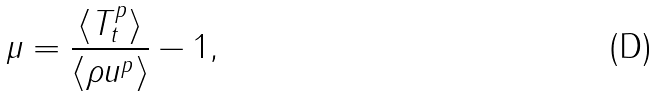<formula> <loc_0><loc_0><loc_500><loc_500>\mu = \frac { \langle T _ { t } ^ { p } \rangle } { \langle \rho u ^ { p } \rangle } - 1 ,</formula> 